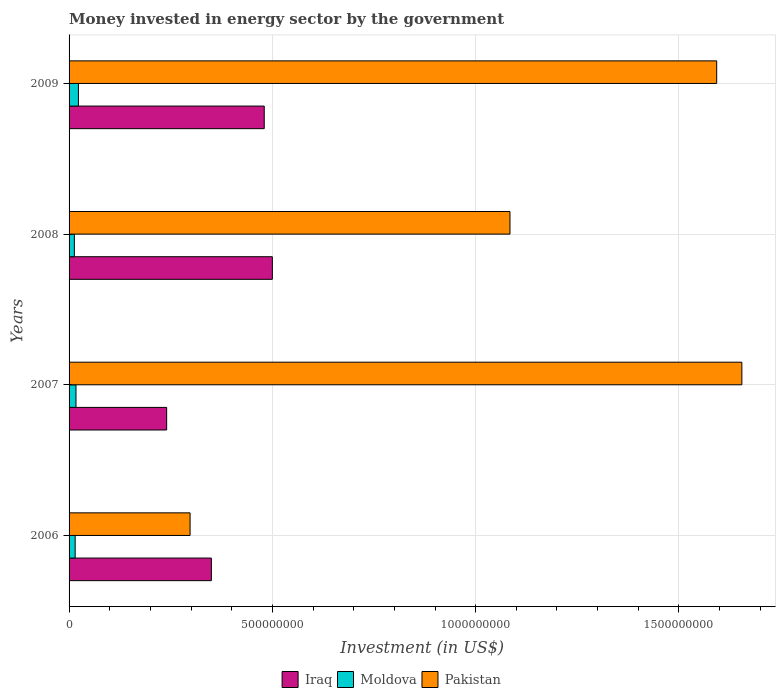How many different coloured bars are there?
Your answer should be very brief. 3. Are the number of bars per tick equal to the number of legend labels?
Provide a short and direct response. Yes. Are the number of bars on each tick of the Y-axis equal?
Ensure brevity in your answer.  Yes. How many bars are there on the 1st tick from the bottom?
Offer a terse response. 3. In how many cases, is the number of bars for a given year not equal to the number of legend labels?
Your answer should be very brief. 0. What is the money spent in energy sector in Iraq in 2008?
Ensure brevity in your answer.  5.00e+08. Across all years, what is the maximum money spent in energy sector in Moldova?
Provide a succinct answer. 2.30e+07. Across all years, what is the minimum money spent in energy sector in Moldova?
Provide a succinct answer. 1.30e+07. What is the total money spent in energy sector in Moldova in the graph?
Your answer should be compact. 6.80e+07. What is the difference between the money spent in energy sector in Pakistan in 2006 and that in 2009?
Give a very brief answer. -1.30e+09. What is the difference between the money spent in energy sector in Pakistan in 2009 and the money spent in energy sector in Iraq in 2007?
Offer a terse response. 1.35e+09. What is the average money spent in energy sector in Iraq per year?
Make the answer very short. 3.92e+08. In the year 2006, what is the difference between the money spent in energy sector in Iraq and money spent in energy sector in Pakistan?
Provide a short and direct response. 5.24e+07. In how many years, is the money spent in energy sector in Iraq greater than 600000000 US$?
Make the answer very short. 0. What is the ratio of the money spent in energy sector in Iraq in 2006 to that in 2009?
Give a very brief answer. 0.73. Is the difference between the money spent in energy sector in Iraq in 2008 and 2009 greater than the difference between the money spent in energy sector in Pakistan in 2008 and 2009?
Provide a succinct answer. Yes. What is the difference between the highest and the lowest money spent in energy sector in Iraq?
Keep it short and to the point. 2.60e+08. What does the 2nd bar from the top in 2009 represents?
Your answer should be very brief. Moldova. What does the 1st bar from the bottom in 2008 represents?
Ensure brevity in your answer.  Iraq. Is it the case that in every year, the sum of the money spent in energy sector in Pakistan and money spent in energy sector in Moldova is greater than the money spent in energy sector in Iraq?
Provide a succinct answer. No. Are all the bars in the graph horizontal?
Provide a short and direct response. Yes. What is the difference between two consecutive major ticks on the X-axis?
Offer a terse response. 5.00e+08. Are the values on the major ticks of X-axis written in scientific E-notation?
Your answer should be compact. No. Does the graph contain grids?
Offer a terse response. Yes. Where does the legend appear in the graph?
Give a very brief answer. Bottom center. How many legend labels are there?
Provide a succinct answer. 3. How are the legend labels stacked?
Provide a succinct answer. Horizontal. What is the title of the graph?
Give a very brief answer. Money invested in energy sector by the government. Does "Brazil" appear as one of the legend labels in the graph?
Your answer should be compact. No. What is the label or title of the X-axis?
Your answer should be very brief. Investment (in US$). What is the Investment (in US$) in Iraq in 2006?
Keep it short and to the point. 3.50e+08. What is the Investment (in US$) of Moldova in 2006?
Keep it short and to the point. 1.50e+07. What is the Investment (in US$) in Pakistan in 2006?
Provide a succinct answer. 2.98e+08. What is the Investment (in US$) in Iraq in 2007?
Make the answer very short. 2.40e+08. What is the Investment (in US$) in Moldova in 2007?
Provide a short and direct response. 1.70e+07. What is the Investment (in US$) of Pakistan in 2007?
Your answer should be compact. 1.65e+09. What is the Investment (in US$) in Iraq in 2008?
Offer a terse response. 5.00e+08. What is the Investment (in US$) in Moldova in 2008?
Offer a very short reply. 1.30e+07. What is the Investment (in US$) in Pakistan in 2008?
Your answer should be very brief. 1.08e+09. What is the Investment (in US$) of Iraq in 2009?
Your answer should be very brief. 4.80e+08. What is the Investment (in US$) of Moldova in 2009?
Provide a short and direct response. 2.30e+07. What is the Investment (in US$) in Pakistan in 2009?
Make the answer very short. 1.59e+09. Across all years, what is the maximum Investment (in US$) in Iraq?
Your answer should be very brief. 5.00e+08. Across all years, what is the maximum Investment (in US$) of Moldova?
Provide a short and direct response. 2.30e+07. Across all years, what is the maximum Investment (in US$) of Pakistan?
Offer a very short reply. 1.65e+09. Across all years, what is the minimum Investment (in US$) of Iraq?
Ensure brevity in your answer.  2.40e+08. Across all years, what is the minimum Investment (in US$) in Moldova?
Provide a short and direct response. 1.30e+07. Across all years, what is the minimum Investment (in US$) of Pakistan?
Offer a very short reply. 2.98e+08. What is the total Investment (in US$) of Iraq in the graph?
Keep it short and to the point. 1.57e+09. What is the total Investment (in US$) in Moldova in the graph?
Your answer should be very brief. 6.80e+07. What is the total Investment (in US$) of Pakistan in the graph?
Give a very brief answer. 4.63e+09. What is the difference between the Investment (in US$) of Iraq in 2006 and that in 2007?
Your answer should be compact. 1.10e+08. What is the difference between the Investment (in US$) in Pakistan in 2006 and that in 2007?
Your answer should be very brief. -1.36e+09. What is the difference between the Investment (in US$) of Iraq in 2006 and that in 2008?
Keep it short and to the point. -1.50e+08. What is the difference between the Investment (in US$) in Moldova in 2006 and that in 2008?
Provide a succinct answer. 2.00e+06. What is the difference between the Investment (in US$) of Pakistan in 2006 and that in 2008?
Ensure brevity in your answer.  -7.87e+08. What is the difference between the Investment (in US$) of Iraq in 2006 and that in 2009?
Make the answer very short. -1.30e+08. What is the difference between the Investment (in US$) in Moldova in 2006 and that in 2009?
Ensure brevity in your answer.  -8.00e+06. What is the difference between the Investment (in US$) in Pakistan in 2006 and that in 2009?
Offer a very short reply. -1.30e+09. What is the difference between the Investment (in US$) of Iraq in 2007 and that in 2008?
Ensure brevity in your answer.  -2.60e+08. What is the difference between the Investment (in US$) in Moldova in 2007 and that in 2008?
Ensure brevity in your answer.  4.00e+06. What is the difference between the Investment (in US$) of Pakistan in 2007 and that in 2008?
Keep it short and to the point. 5.70e+08. What is the difference between the Investment (in US$) of Iraq in 2007 and that in 2009?
Offer a terse response. -2.40e+08. What is the difference between the Investment (in US$) of Moldova in 2007 and that in 2009?
Provide a short and direct response. -6.00e+06. What is the difference between the Investment (in US$) of Pakistan in 2007 and that in 2009?
Offer a terse response. 6.19e+07. What is the difference between the Investment (in US$) of Moldova in 2008 and that in 2009?
Your answer should be compact. -1.00e+07. What is the difference between the Investment (in US$) of Pakistan in 2008 and that in 2009?
Give a very brief answer. -5.08e+08. What is the difference between the Investment (in US$) in Iraq in 2006 and the Investment (in US$) in Moldova in 2007?
Give a very brief answer. 3.33e+08. What is the difference between the Investment (in US$) of Iraq in 2006 and the Investment (in US$) of Pakistan in 2007?
Your answer should be compact. -1.30e+09. What is the difference between the Investment (in US$) of Moldova in 2006 and the Investment (in US$) of Pakistan in 2007?
Offer a terse response. -1.64e+09. What is the difference between the Investment (in US$) in Iraq in 2006 and the Investment (in US$) in Moldova in 2008?
Offer a terse response. 3.37e+08. What is the difference between the Investment (in US$) in Iraq in 2006 and the Investment (in US$) in Pakistan in 2008?
Keep it short and to the point. -7.34e+08. What is the difference between the Investment (in US$) in Moldova in 2006 and the Investment (in US$) in Pakistan in 2008?
Offer a terse response. -1.07e+09. What is the difference between the Investment (in US$) of Iraq in 2006 and the Investment (in US$) of Moldova in 2009?
Your response must be concise. 3.27e+08. What is the difference between the Investment (in US$) in Iraq in 2006 and the Investment (in US$) in Pakistan in 2009?
Your response must be concise. -1.24e+09. What is the difference between the Investment (in US$) of Moldova in 2006 and the Investment (in US$) of Pakistan in 2009?
Your answer should be compact. -1.58e+09. What is the difference between the Investment (in US$) of Iraq in 2007 and the Investment (in US$) of Moldova in 2008?
Give a very brief answer. 2.27e+08. What is the difference between the Investment (in US$) of Iraq in 2007 and the Investment (in US$) of Pakistan in 2008?
Your answer should be compact. -8.44e+08. What is the difference between the Investment (in US$) in Moldova in 2007 and the Investment (in US$) in Pakistan in 2008?
Give a very brief answer. -1.07e+09. What is the difference between the Investment (in US$) in Iraq in 2007 and the Investment (in US$) in Moldova in 2009?
Offer a very short reply. 2.17e+08. What is the difference between the Investment (in US$) in Iraq in 2007 and the Investment (in US$) in Pakistan in 2009?
Your answer should be compact. -1.35e+09. What is the difference between the Investment (in US$) of Moldova in 2007 and the Investment (in US$) of Pakistan in 2009?
Your answer should be compact. -1.58e+09. What is the difference between the Investment (in US$) of Iraq in 2008 and the Investment (in US$) of Moldova in 2009?
Make the answer very short. 4.77e+08. What is the difference between the Investment (in US$) of Iraq in 2008 and the Investment (in US$) of Pakistan in 2009?
Give a very brief answer. -1.09e+09. What is the difference between the Investment (in US$) in Moldova in 2008 and the Investment (in US$) in Pakistan in 2009?
Your response must be concise. -1.58e+09. What is the average Investment (in US$) of Iraq per year?
Provide a succinct answer. 3.92e+08. What is the average Investment (in US$) of Moldova per year?
Provide a succinct answer. 1.70e+07. What is the average Investment (in US$) in Pakistan per year?
Your answer should be compact. 1.16e+09. In the year 2006, what is the difference between the Investment (in US$) of Iraq and Investment (in US$) of Moldova?
Make the answer very short. 3.35e+08. In the year 2006, what is the difference between the Investment (in US$) of Iraq and Investment (in US$) of Pakistan?
Provide a short and direct response. 5.24e+07. In the year 2006, what is the difference between the Investment (in US$) in Moldova and Investment (in US$) in Pakistan?
Provide a succinct answer. -2.83e+08. In the year 2007, what is the difference between the Investment (in US$) of Iraq and Investment (in US$) of Moldova?
Offer a very short reply. 2.23e+08. In the year 2007, what is the difference between the Investment (in US$) of Iraq and Investment (in US$) of Pakistan?
Offer a terse response. -1.41e+09. In the year 2007, what is the difference between the Investment (in US$) of Moldova and Investment (in US$) of Pakistan?
Your answer should be compact. -1.64e+09. In the year 2008, what is the difference between the Investment (in US$) in Iraq and Investment (in US$) in Moldova?
Your answer should be compact. 4.87e+08. In the year 2008, what is the difference between the Investment (in US$) in Iraq and Investment (in US$) in Pakistan?
Keep it short and to the point. -5.84e+08. In the year 2008, what is the difference between the Investment (in US$) of Moldova and Investment (in US$) of Pakistan?
Your answer should be very brief. -1.07e+09. In the year 2009, what is the difference between the Investment (in US$) of Iraq and Investment (in US$) of Moldova?
Your answer should be very brief. 4.57e+08. In the year 2009, what is the difference between the Investment (in US$) of Iraq and Investment (in US$) of Pakistan?
Your answer should be very brief. -1.11e+09. In the year 2009, what is the difference between the Investment (in US$) of Moldova and Investment (in US$) of Pakistan?
Your response must be concise. -1.57e+09. What is the ratio of the Investment (in US$) in Iraq in 2006 to that in 2007?
Offer a terse response. 1.46. What is the ratio of the Investment (in US$) of Moldova in 2006 to that in 2007?
Ensure brevity in your answer.  0.88. What is the ratio of the Investment (in US$) in Pakistan in 2006 to that in 2007?
Ensure brevity in your answer.  0.18. What is the ratio of the Investment (in US$) in Moldova in 2006 to that in 2008?
Your answer should be compact. 1.15. What is the ratio of the Investment (in US$) in Pakistan in 2006 to that in 2008?
Give a very brief answer. 0.27. What is the ratio of the Investment (in US$) in Iraq in 2006 to that in 2009?
Offer a very short reply. 0.73. What is the ratio of the Investment (in US$) of Moldova in 2006 to that in 2009?
Keep it short and to the point. 0.65. What is the ratio of the Investment (in US$) of Pakistan in 2006 to that in 2009?
Provide a succinct answer. 0.19. What is the ratio of the Investment (in US$) of Iraq in 2007 to that in 2008?
Offer a very short reply. 0.48. What is the ratio of the Investment (in US$) of Moldova in 2007 to that in 2008?
Provide a short and direct response. 1.31. What is the ratio of the Investment (in US$) of Pakistan in 2007 to that in 2008?
Keep it short and to the point. 1.53. What is the ratio of the Investment (in US$) of Moldova in 2007 to that in 2009?
Provide a succinct answer. 0.74. What is the ratio of the Investment (in US$) in Pakistan in 2007 to that in 2009?
Keep it short and to the point. 1.04. What is the ratio of the Investment (in US$) in Iraq in 2008 to that in 2009?
Make the answer very short. 1.04. What is the ratio of the Investment (in US$) in Moldova in 2008 to that in 2009?
Your response must be concise. 0.57. What is the ratio of the Investment (in US$) in Pakistan in 2008 to that in 2009?
Your answer should be very brief. 0.68. What is the difference between the highest and the second highest Investment (in US$) in Iraq?
Offer a terse response. 2.00e+07. What is the difference between the highest and the second highest Investment (in US$) of Pakistan?
Offer a very short reply. 6.19e+07. What is the difference between the highest and the lowest Investment (in US$) of Iraq?
Ensure brevity in your answer.  2.60e+08. What is the difference between the highest and the lowest Investment (in US$) in Moldova?
Provide a succinct answer. 1.00e+07. What is the difference between the highest and the lowest Investment (in US$) in Pakistan?
Make the answer very short. 1.36e+09. 